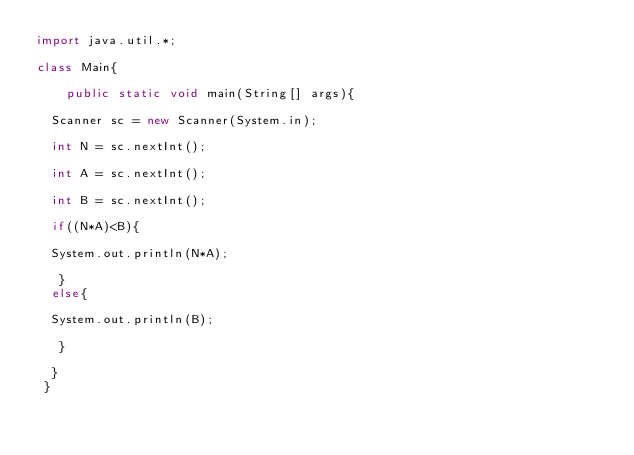<code> <loc_0><loc_0><loc_500><loc_500><_Java_>import java.util.*;

class Main{
	
    public static void main(String[] args){

	Scanner sc = new Scanner(System.in);

	int N = sc.nextInt();

	int A = sc.nextInt();

	int B = sc.nextInt();

	if((N*A)<B){

	System.out.println(N*A);	

   }
	else{

	System.out.println(B);
 
   } 

  }
 }</code> 